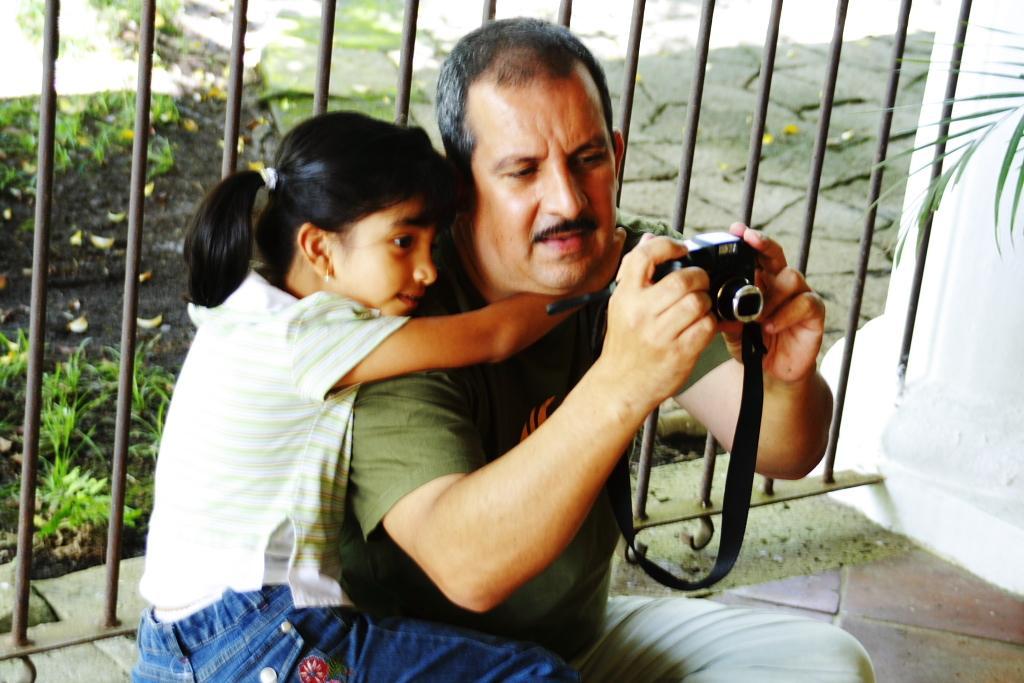Could you give a brief overview of what you see in this image? In this image this this child is holding the man and looking into the camera. In the background there is a fence and grass. 